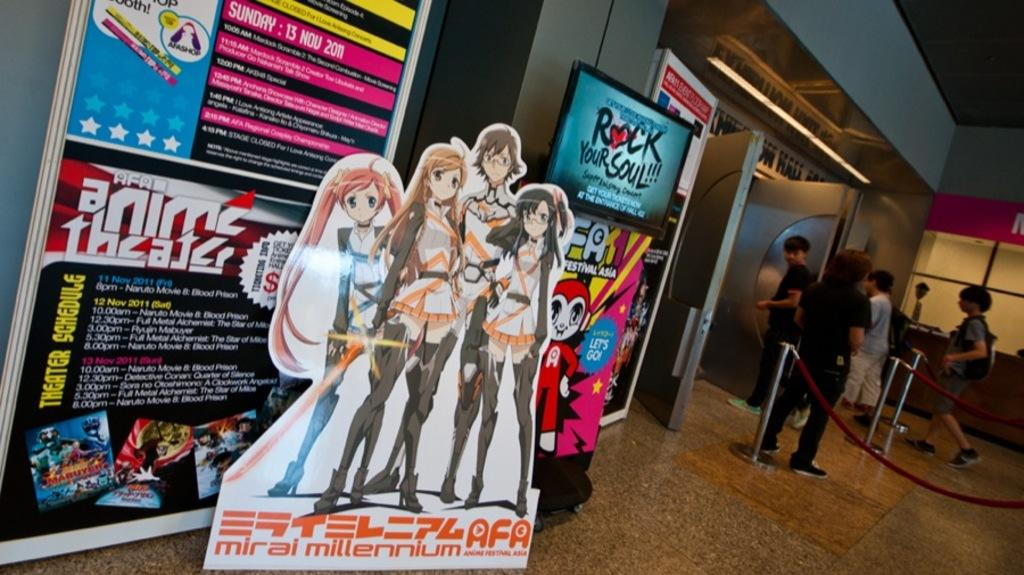<image>
Present a compact description of the photo's key features. An anime display shows a Japanese anime from mirai millennium. 